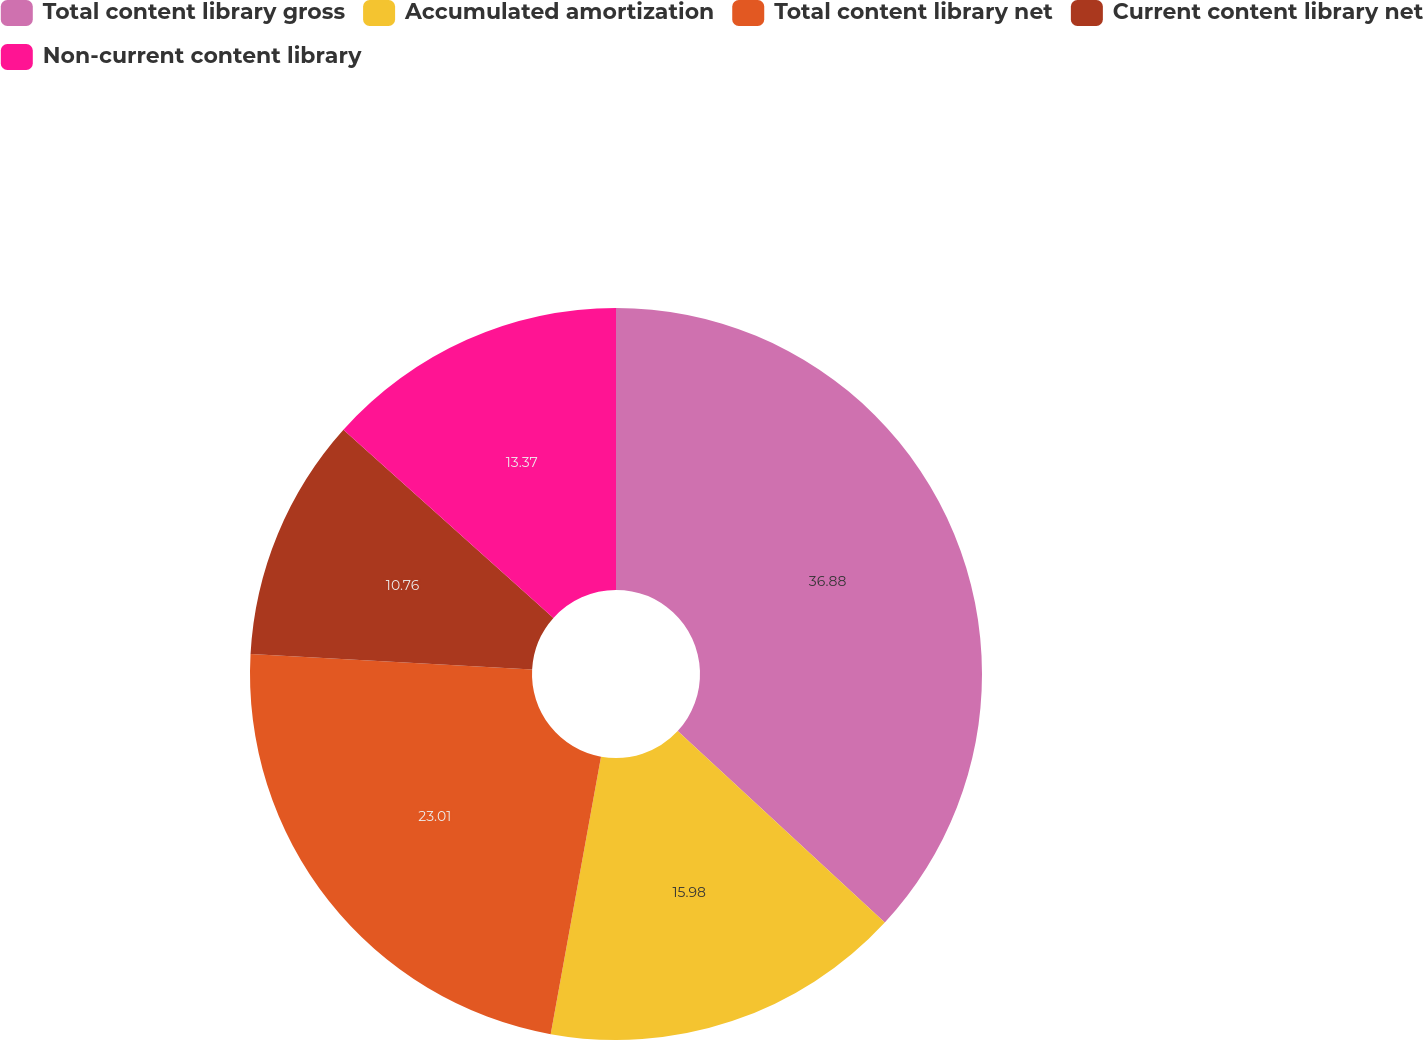<chart> <loc_0><loc_0><loc_500><loc_500><pie_chart><fcel>Total content library gross<fcel>Accumulated amortization<fcel>Total content library net<fcel>Current content library net<fcel>Non-current content library<nl><fcel>36.87%<fcel>15.98%<fcel>23.01%<fcel>10.76%<fcel>13.37%<nl></chart> 